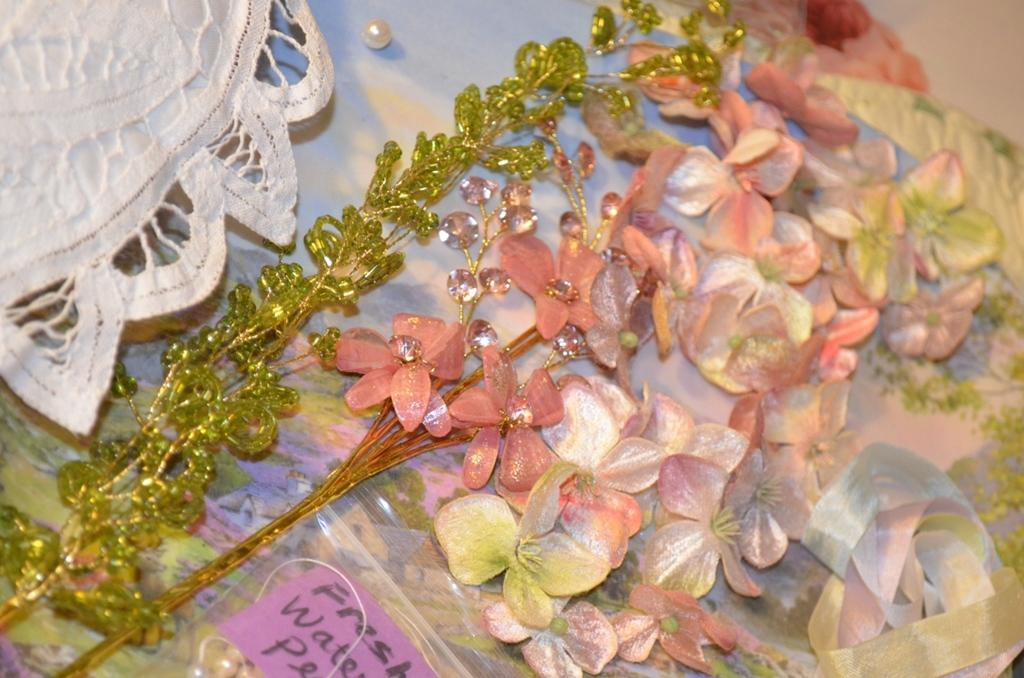What type of living organisms can be seen in the image? There are flowers in the image. What color is the paper visible in the image? The paper in the image is pink. What type of guide can be seen in the image? There is no guide present in the image. What is the color of the cream visible in the image? There is no cream visible in the image. 